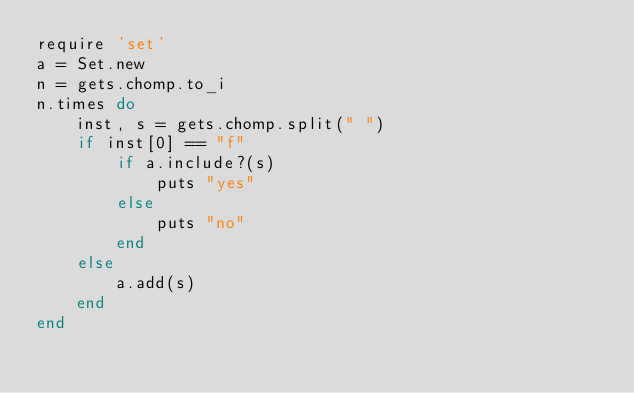<code> <loc_0><loc_0><loc_500><loc_500><_Ruby_>require 'set'
a = Set.new
n = gets.chomp.to_i
n.times do
    inst, s = gets.chomp.split(" ")
    if inst[0] == "f"
        if a.include?(s)
            puts "yes"
        else
            puts "no"
        end
    else
        a.add(s)
    end
end</code> 